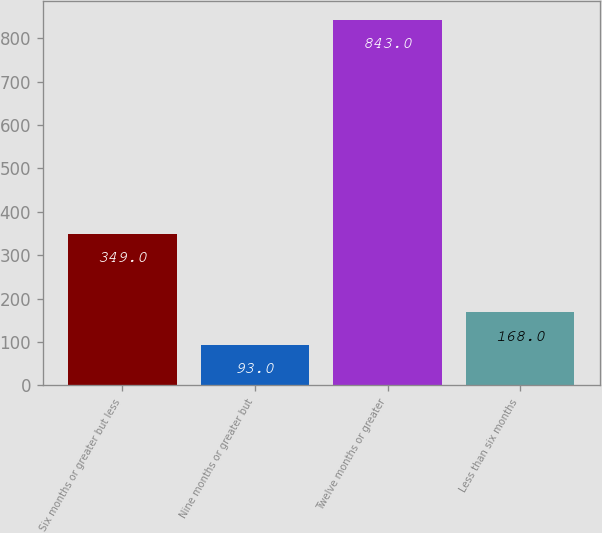Convert chart. <chart><loc_0><loc_0><loc_500><loc_500><bar_chart><fcel>Six months or greater but less<fcel>Nine months or greater but<fcel>Twelve months or greater<fcel>Less than six months<nl><fcel>349<fcel>93<fcel>843<fcel>168<nl></chart> 